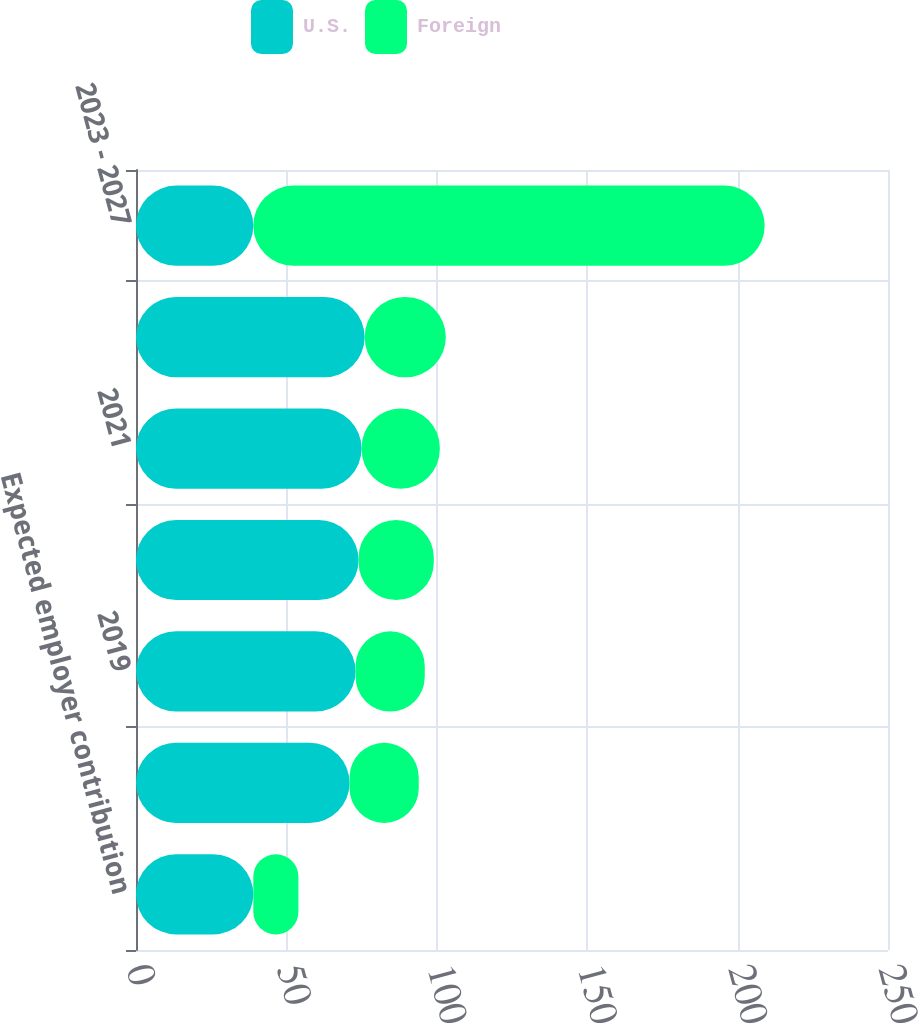Convert chart. <chart><loc_0><loc_0><loc_500><loc_500><stacked_bar_chart><ecel><fcel>Expected employer contribution<fcel>2018<fcel>2019<fcel>2020<fcel>2021<fcel>2022<fcel>2023 - 2027<nl><fcel>U.S.<fcel>39<fcel>71<fcel>73<fcel>74<fcel>75<fcel>76<fcel>39<nl><fcel>Foreign<fcel>15<fcel>23<fcel>23<fcel>25<fcel>26<fcel>27<fcel>170<nl></chart> 